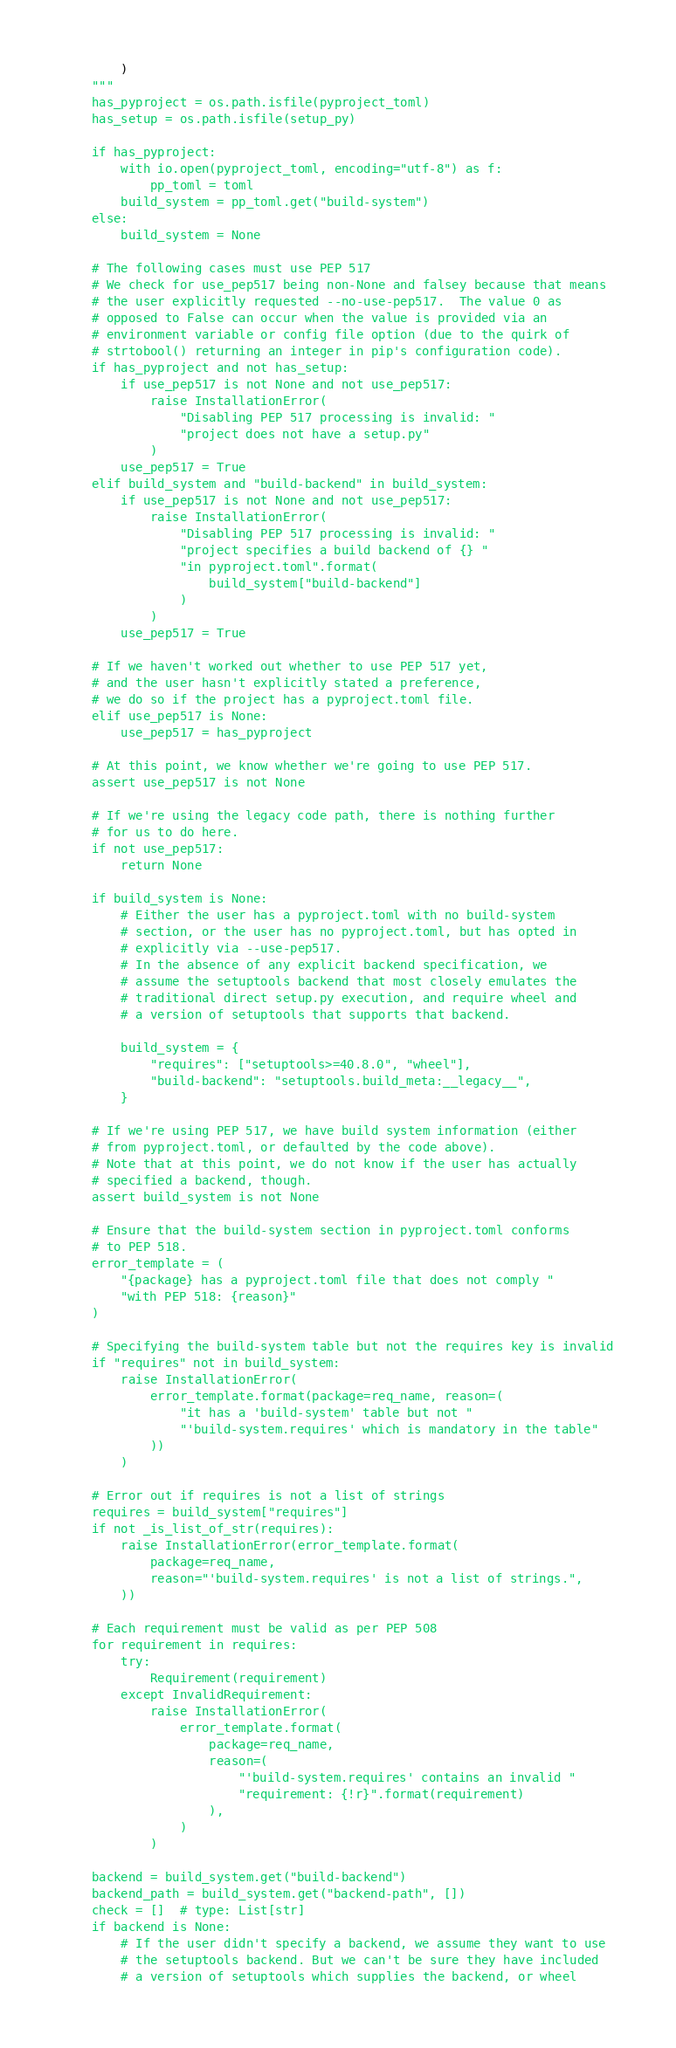<code> <loc_0><loc_0><loc_500><loc_500><_Python_>        )
    """
    has_pyproject = os.path.isfile(pyproject_toml)
    has_setup = os.path.isfile(setup_py)

    if has_pyproject:
        with io.open(pyproject_toml, encoding="utf-8") as f:
            pp_toml = toml
        build_system = pp_toml.get("build-system")
    else:
        build_system = None

    # The following cases must use PEP 517
    # We check for use_pep517 being non-None and falsey because that means
    # the user explicitly requested --no-use-pep517.  The value 0 as
    # opposed to False can occur when the value is provided via an
    # environment variable or config file option (due to the quirk of
    # strtobool() returning an integer in pip's configuration code).
    if has_pyproject and not has_setup:
        if use_pep517 is not None and not use_pep517:
            raise InstallationError(
                "Disabling PEP 517 processing is invalid: "
                "project does not have a setup.py"
            )
        use_pep517 = True
    elif build_system and "build-backend" in build_system:
        if use_pep517 is not None and not use_pep517:
            raise InstallationError(
                "Disabling PEP 517 processing is invalid: "
                "project specifies a build backend of {} "
                "in pyproject.toml".format(
                    build_system["build-backend"]
                )
            )
        use_pep517 = True

    # If we haven't worked out whether to use PEP 517 yet,
    # and the user hasn't explicitly stated a preference,
    # we do so if the project has a pyproject.toml file.
    elif use_pep517 is None:
        use_pep517 = has_pyproject

    # At this point, we know whether we're going to use PEP 517.
    assert use_pep517 is not None

    # If we're using the legacy code path, there is nothing further
    # for us to do here.
    if not use_pep517:
        return None

    if build_system is None:
        # Either the user has a pyproject.toml with no build-system
        # section, or the user has no pyproject.toml, but has opted in
        # explicitly via --use-pep517.
        # In the absence of any explicit backend specification, we
        # assume the setuptools backend that most closely emulates the
        # traditional direct setup.py execution, and require wheel and
        # a version of setuptools that supports that backend.

        build_system = {
            "requires": ["setuptools>=40.8.0", "wheel"],
            "build-backend": "setuptools.build_meta:__legacy__",
        }

    # If we're using PEP 517, we have build system information (either
    # from pyproject.toml, or defaulted by the code above).
    # Note that at this point, we do not know if the user has actually
    # specified a backend, though.
    assert build_system is not None

    # Ensure that the build-system section in pyproject.toml conforms
    # to PEP 518.
    error_template = (
        "{package} has a pyproject.toml file that does not comply "
        "with PEP 518: {reason}"
    )

    # Specifying the build-system table but not the requires key is invalid
    if "requires" not in build_system:
        raise InstallationError(
            error_template.format(package=req_name, reason=(
                "it has a 'build-system' table but not "
                "'build-system.requires' which is mandatory in the table"
            ))
        )

    # Error out if requires is not a list of strings
    requires = build_system["requires"]
    if not _is_list_of_str(requires):
        raise InstallationError(error_template.format(
            package=req_name,
            reason="'build-system.requires' is not a list of strings.",
        ))

    # Each requirement must be valid as per PEP 508
    for requirement in requires:
        try:
            Requirement(requirement)
        except InvalidRequirement:
            raise InstallationError(
                error_template.format(
                    package=req_name,
                    reason=(
                        "'build-system.requires' contains an invalid "
                        "requirement: {!r}".format(requirement)
                    ),
                )
            )

    backend = build_system.get("build-backend")
    backend_path = build_system.get("backend-path", [])
    check = []  # type: List[str]
    if backend is None:
        # If the user didn't specify a backend, we assume they want to use
        # the setuptools backend. But we can't be sure they have included
        # a version of setuptools which supplies the backend, or wheel</code> 